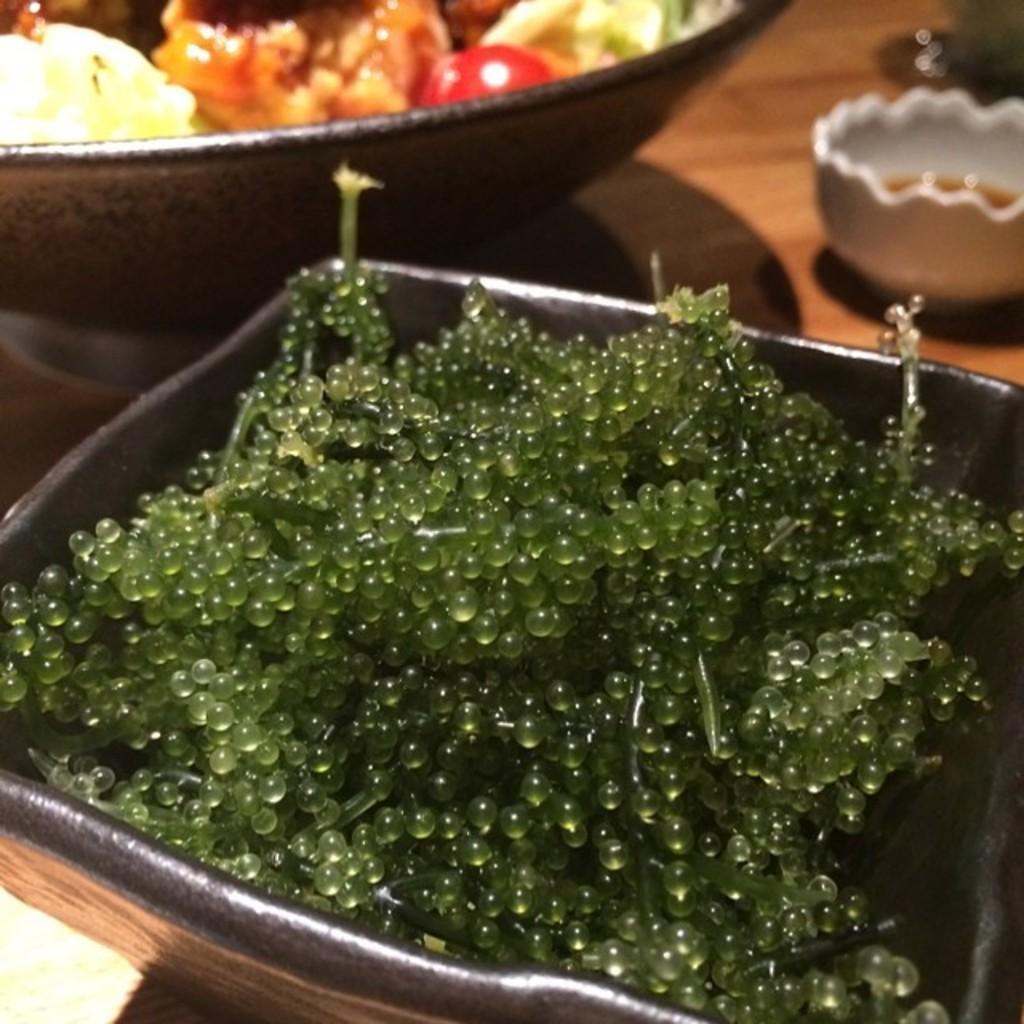How would you summarize this image in a sentence or two? In this picture there is a table, on the table there are bowls served with different dishes. In the foreground there are gelatin balls. 